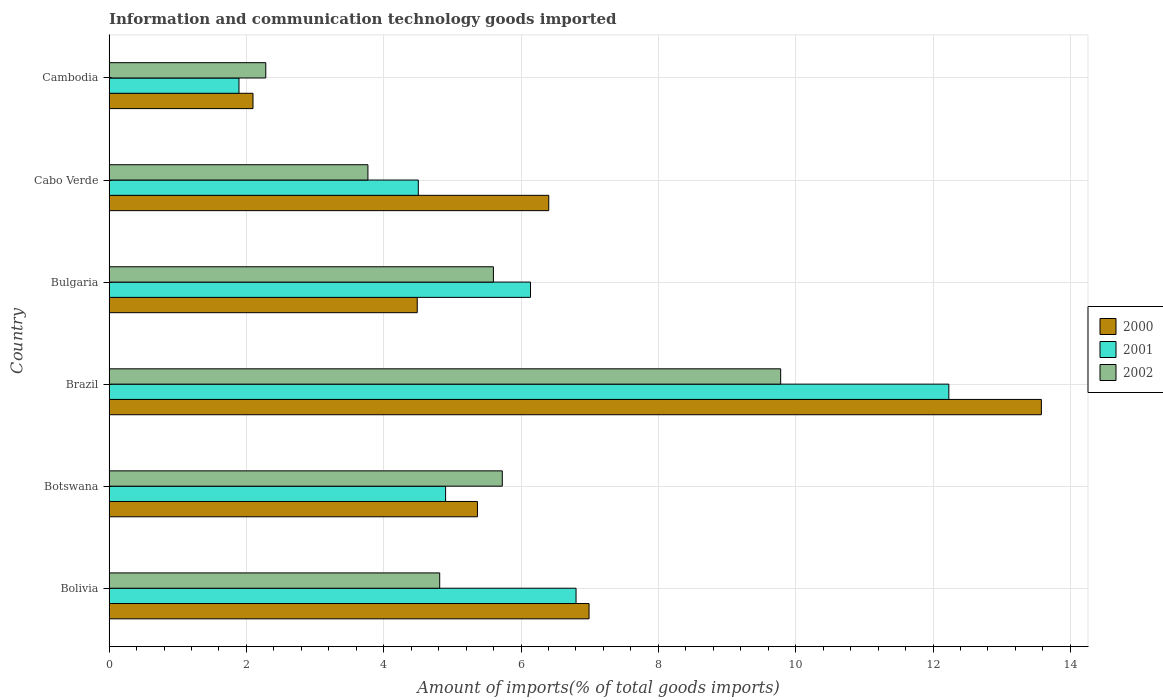Are the number of bars per tick equal to the number of legend labels?
Your response must be concise. Yes. How many bars are there on the 6th tick from the top?
Your answer should be very brief. 3. What is the amount of goods imported in 2002 in Botswana?
Give a very brief answer. 5.73. Across all countries, what is the maximum amount of goods imported in 2002?
Give a very brief answer. 9.78. Across all countries, what is the minimum amount of goods imported in 2000?
Keep it short and to the point. 2.1. In which country was the amount of goods imported in 2002 minimum?
Your answer should be very brief. Cambodia. What is the total amount of goods imported in 2002 in the graph?
Your response must be concise. 31.97. What is the difference between the amount of goods imported in 2002 in Botswana and that in Brazil?
Make the answer very short. -4.05. What is the difference between the amount of goods imported in 2002 in Brazil and the amount of goods imported in 2001 in Botswana?
Offer a terse response. 4.88. What is the average amount of goods imported in 2002 per country?
Give a very brief answer. 5.33. What is the difference between the amount of goods imported in 2001 and amount of goods imported in 2000 in Brazil?
Ensure brevity in your answer.  -1.35. In how many countries, is the amount of goods imported in 2000 greater than 9.2 %?
Offer a terse response. 1. What is the ratio of the amount of goods imported in 2001 in Bolivia to that in Bulgaria?
Keep it short and to the point. 1.11. Is the amount of goods imported in 2001 in Bolivia less than that in Brazil?
Ensure brevity in your answer.  Yes. Is the difference between the amount of goods imported in 2001 in Bolivia and Cambodia greater than the difference between the amount of goods imported in 2000 in Bolivia and Cambodia?
Offer a very short reply. Yes. What is the difference between the highest and the second highest amount of goods imported in 2001?
Ensure brevity in your answer.  5.43. What is the difference between the highest and the lowest amount of goods imported in 2002?
Make the answer very short. 7.5. In how many countries, is the amount of goods imported in 2002 greater than the average amount of goods imported in 2002 taken over all countries?
Offer a terse response. 3. Is the sum of the amount of goods imported in 2000 in Cabo Verde and Cambodia greater than the maximum amount of goods imported in 2001 across all countries?
Offer a very short reply. No. Is it the case that in every country, the sum of the amount of goods imported in 2001 and amount of goods imported in 2002 is greater than the amount of goods imported in 2000?
Your answer should be compact. Yes. How many bars are there?
Provide a short and direct response. 18. Are all the bars in the graph horizontal?
Ensure brevity in your answer.  Yes. How many countries are there in the graph?
Offer a very short reply. 6. What is the difference between two consecutive major ticks on the X-axis?
Give a very brief answer. 2. Are the values on the major ticks of X-axis written in scientific E-notation?
Give a very brief answer. No. How many legend labels are there?
Offer a very short reply. 3. How are the legend labels stacked?
Provide a succinct answer. Vertical. What is the title of the graph?
Make the answer very short. Information and communication technology goods imported. Does "1997" appear as one of the legend labels in the graph?
Offer a very short reply. No. What is the label or title of the X-axis?
Give a very brief answer. Amount of imports(% of total goods imports). What is the Amount of imports(% of total goods imports) of 2000 in Bolivia?
Your answer should be very brief. 6.99. What is the Amount of imports(% of total goods imports) in 2001 in Bolivia?
Offer a very short reply. 6.8. What is the Amount of imports(% of total goods imports) of 2002 in Bolivia?
Keep it short and to the point. 4.82. What is the Amount of imports(% of total goods imports) in 2000 in Botswana?
Your answer should be very brief. 5.37. What is the Amount of imports(% of total goods imports) in 2001 in Botswana?
Give a very brief answer. 4.9. What is the Amount of imports(% of total goods imports) in 2002 in Botswana?
Offer a very short reply. 5.73. What is the Amount of imports(% of total goods imports) in 2000 in Brazil?
Your answer should be compact. 13.58. What is the Amount of imports(% of total goods imports) of 2001 in Brazil?
Make the answer very short. 12.23. What is the Amount of imports(% of total goods imports) in 2002 in Brazil?
Make the answer very short. 9.78. What is the Amount of imports(% of total goods imports) of 2000 in Bulgaria?
Offer a terse response. 4.49. What is the Amount of imports(% of total goods imports) of 2001 in Bulgaria?
Ensure brevity in your answer.  6.14. What is the Amount of imports(% of total goods imports) in 2002 in Bulgaria?
Give a very brief answer. 5.6. What is the Amount of imports(% of total goods imports) of 2000 in Cabo Verde?
Your answer should be compact. 6.4. What is the Amount of imports(% of total goods imports) in 2001 in Cabo Verde?
Give a very brief answer. 4.5. What is the Amount of imports(% of total goods imports) of 2002 in Cabo Verde?
Your answer should be very brief. 3.77. What is the Amount of imports(% of total goods imports) of 2000 in Cambodia?
Give a very brief answer. 2.1. What is the Amount of imports(% of total goods imports) of 2001 in Cambodia?
Provide a short and direct response. 1.89. What is the Amount of imports(% of total goods imports) of 2002 in Cambodia?
Your response must be concise. 2.28. Across all countries, what is the maximum Amount of imports(% of total goods imports) of 2000?
Provide a short and direct response. 13.58. Across all countries, what is the maximum Amount of imports(% of total goods imports) in 2001?
Give a very brief answer. 12.23. Across all countries, what is the maximum Amount of imports(% of total goods imports) of 2002?
Your response must be concise. 9.78. Across all countries, what is the minimum Amount of imports(% of total goods imports) in 2000?
Your answer should be compact. 2.1. Across all countries, what is the minimum Amount of imports(% of total goods imports) in 2001?
Offer a very short reply. 1.89. Across all countries, what is the minimum Amount of imports(% of total goods imports) of 2002?
Make the answer very short. 2.28. What is the total Amount of imports(% of total goods imports) in 2000 in the graph?
Your answer should be very brief. 38.92. What is the total Amount of imports(% of total goods imports) of 2001 in the graph?
Provide a succinct answer. 36.47. What is the total Amount of imports(% of total goods imports) in 2002 in the graph?
Offer a terse response. 31.97. What is the difference between the Amount of imports(% of total goods imports) of 2000 in Bolivia and that in Botswana?
Keep it short and to the point. 1.63. What is the difference between the Amount of imports(% of total goods imports) of 2001 in Bolivia and that in Botswana?
Give a very brief answer. 1.9. What is the difference between the Amount of imports(% of total goods imports) in 2002 in Bolivia and that in Botswana?
Provide a succinct answer. -0.91. What is the difference between the Amount of imports(% of total goods imports) in 2000 in Bolivia and that in Brazil?
Ensure brevity in your answer.  -6.59. What is the difference between the Amount of imports(% of total goods imports) of 2001 in Bolivia and that in Brazil?
Provide a succinct answer. -5.43. What is the difference between the Amount of imports(% of total goods imports) of 2002 in Bolivia and that in Brazil?
Your answer should be compact. -4.97. What is the difference between the Amount of imports(% of total goods imports) of 2000 in Bolivia and that in Bulgaria?
Make the answer very short. 2.5. What is the difference between the Amount of imports(% of total goods imports) in 2001 in Bolivia and that in Bulgaria?
Offer a terse response. 0.66. What is the difference between the Amount of imports(% of total goods imports) of 2002 in Bolivia and that in Bulgaria?
Provide a succinct answer. -0.78. What is the difference between the Amount of imports(% of total goods imports) of 2000 in Bolivia and that in Cabo Verde?
Give a very brief answer. 0.59. What is the difference between the Amount of imports(% of total goods imports) in 2001 in Bolivia and that in Cabo Verde?
Keep it short and to the point. 2.3. What is the difference between the Amount of imports(% of total goods imports) in 2002 in Bolivia and that in Cabo Verde?
Provide a short and direct response. 1.05. What is the difference between the Amount of imports(% of total goods imports) of 2000 in Bolivia and that in Cambodia?
Offer a terse response. 4.89. What is the difference between the Amount of imports(% of total goods imports) in 2001 in Bolivia and that in Cambodia?
Keep it short and to the point. 4.91. What is the difference between the Amount of imports(% of total goods imports) in 2002 in Bolivia and that in Cambodia?
Offer a very short reply. 2.53. What is the difference between the Amount of imports(% of total goods imports) of 2000 in Botswana and that in Brazil?
Make the answer very short. -8.21. What is the difference between the Amount of imports(% of total goods imports) of 2001 in Botswana and that in Brazil?
Your answer should be very brief. -7.33. What is the difference between the Amount of imports(% of total goods imports) in 2002 in Botswana and that in Brazil?
Your response must be concise. -4.05. What is the difference between the Amount of imports(% of total goods imports) in 2000 in Botswana and that in Bulgaria?
Your response must be concise. 0.88. What is the difference between the Amount of imports(% of total goods imports) in 2001 in Botswana and that in Bulgaria?
Offer a very short reply. -1.24. What is the difference between the Amount of imports(% of total goods imports) of 2002 in Botswana and that in Bulgaria?
Give a very brief answer. 0.13. What is the difference between the Amount of imports(% of total goods imports) in 2000 in Botswana and that in Cabo Verde?
Give a very brief answer. -1.04. What is the difference between the Amount of imports(% of total goods imports) of 2001 in Botswana and that in Cabo Verde?
Offer a terse response. 0.4. What is the difference between the Amount of imports(% of total goods imports) of 2002 in Botswana and that in Cabo Verde?
Provide a succinct answer. 1.96. What is the difference between the Amount of imports(% of total goods imports) in 2000 in Botswana and that in Cambodia?
Offer a terse response. 3.27. What is the difference between the Amount of imports(% of total goods imports) of 2001 in Botswana and that in Cambodia?
Offer a terse response. 3.01. What is the difference between the Amount of imports(% of total goods imports) in 2002 in Botswana and that in Cambodia?
Your answer should be very brief. 3.44. What is the difference between the Amount of imports(% of total goods imports) in 2000 in Brazil and that in Bulgaria?
Offer a very short reply. 9.09. What is the difference between the Amount of imports(% of total goods imports) of 2001 in Brazil and that in Bulgaria?
Your response must be concise. 6.09. What is the difference between the Amount of imports(% of total goods imports) in 2002 in Brazil and that in Bulgaria?
Make the answer very short. 4.18. What is the difference between the Amount of imports(% of total goods imports) of 2000 in Brazil and that in Cabo Verde?
Provide a short and direct response. 7.17. What is the difference between the Amount of imports(% of total goods imports) in 2001 in Brazil and that in Cabo Verde?
Offer a very short reply. 7.73. What is the difference between the Amount of imports(% of total goods imports) of 2002 in Brazil and that in Cabo Verde?
Offer a terse response. 6.01. What is the difference between the Amount of imports(% of total goods imports) in 2000 in Brazil and that in Cambodia?
Your response must be concise. 11.48. What is the difference between the Amount of imports(% of total goods imports) of 2001 in Brazil and that in Cambodia?
Your response must be concise. 10.34. What is the difference between the Amount of imports(% of total goods imports) in 2002 in Brazil and that in Cambodia?
Offer a very short reply. 7.5. What is the difference between the Amount of imports(% of total goods imports) in 2000 in Bulgaria and that in Cabo Verde?
Provide a succinct answer. -1.92. What is the difference between the Amount of imports(% of total goods imports) of 2001 in Bulgaria and that in Cabo Verde?
Your answer should be compact. 1.63. What is the difference between the Amount of imports(% of total goods imports) of 2002 in Bulgaria and that in Cabo Verde?
Offer a terse response. 1.83. What is the difference between the Amount of imports(% of total goods imports) of 2000 in Bulgaria and that in Cambodia?
Ensure brevity in your answer.  2.39. What is the difference between the Amount of imports(% of total goods imports) in 2001 in Bulgaria and that in Cambodia?
Ensure brevity in your answer.  4.25. What is the difference between the Amount of imports(% of total goods imports) of 2002 in Bulgaria and that in Cambodia?
Give a very brief answer. 3.31. What is the difference between the Amount of imports(% of total goods imports) of 2000 in Cabo Verde and that in Cambodia?
Provide a short and direct response. 4.31. What is the difference between the Amount of imports(% of total goods imports) of 2001 in Cabo Verde and that in Cambodia?
Offer a terse response. 2.61. What is the difference between the Amount of imports(% of total goods imports) in 2002 in Cabo Verde and that in Cambodia?
Your response must be concise. 1.49. What is the difference between the Amount of imports(% of total goods imports) of 2000 in Bolivia and the Amount of imports(% of total goods imports) of 2001 in Botswana?
Provide a succinct answer. 2.09. What is the difference between the Amount of imports(% of total goods imports) of 2000 in Bolivia and the Amount of imports(% of total goods imports) of 2002 in Botswana?
Provide a succinct answer. 1.26. What is the difference between the Amount of imports(% of total goods imports) in 2001 in Bolivia and the Amount of imports(% of total goods imports) in 2002 in Botswana?
Your response must be concise. 1.07. What is the difference between the Amount of imports(% of total goods imports) in 2000 in Bolivia and the Amount of imports(% of total goods imports) in 2001 in Brazil?
Make the answer very short. -5.24. What is the difference between the Amount of imports(% of total goods imports) of 2000 in Bolivia and the Amount of imports(% of total goods imports) of 2002 in Brazil?
Offer a very short reply. -2.79. What is the difference between the Amount of imports(% of total goods imports) in 2001 in Bolivia and the Amount of imports(% of total goods imports) in 2002 in Brazil?
Your answer should be very brief. -2.98. What is the difference between the Amount of imports(% of total goods imports) of 2000 in Bolivia and the Amount of imports(% of total goods imports) of 2001 in Bulgaria?
Your answer should be very brief. 0.85. What is the difference between the Amount of imports(% of total goods imports) of 2000 in Bolivia and the Amount of imports(% of total goods imports) of 2002 in Bulgaria?
Offer a terse response. 1.39. What is the difference between the Amount of imports(% of total goods imports) in 2001 in Bolivia and the Amount of imports(% of total goods imports) in 2002 in Bulgaria?
Your answer should be very brief. 1.2. What is the difference between the Amount of imports(% of total goods imports) in 2000 in Bolivia and the Amount of imports(% of total goods imports) in 2001 in Cabo Verde?
Make the answer very short. 2.49. What is the difference between the Amount of imports(% of total goods imports) in 2000 in Bolivia and the Amount of imports(% of total goods imports) in 2002 in Cabo Verde?
Your answer should be very brief. 3.22. What is the difference between the Amount of imports(% of total goods imports) of 2001 in Bolivia and the Amount of imports(% of total goods imports) of 2002 in Cabo Verde?
Provide a short and direct response. 3.03. What is the difference between the Amount of imports(% of total goods imports) in 2000 in Bolivia and the Amount of imports(% of total goods imports) in 2001 in Cambodia?
Provide a succinct answer. 5.1. What is the difference between the Amount of imports(% of total goods imports) in 2000 in Bolivia and the Amount of imports(% of total goods imports) in 2002 in Cambodia?
Make the answer very short. 4.71. What is the difference between the Amount of imports(% of total goods imports) in 2001 in Bolivia and the Amount of imports(% of total goods imports) in 2002 in Cambodia?
Your answer should be compact. 4.52. What is the difference between the Amount of imports(% of total goods imports) in 2000 in Botswana and the Amount of imports(% of total goods imports) in 2001 in Brazil?
Offer a terse response. -6.87. What is the difference between the Amount of imports(% of total goods imports) of 2000 in Botswana and the Amount of imports(% of total goods imports) of 2002 in Brazil?
Your response must be concise. -4.42. What is the difference between the Amount of imports(% of total goods imports) of 2001 in Botswana and the Amount of imports(% of total goods imports) of 2002 in Brazil?
Make the answer very short. -4.88. What is the difference between the Amount of imports(% of total goods imports) of 2000 in Botswana and the Amount of imports(% of total goods imports) of 2001 in Bulgaria?
Your answer should be compact. -0.77. What is the difference between the Amount of imports(% of total goods imports) of 2000 in Botswana and the Amount of imports(% of total goods imports) of 2002 in Bulgaria?
Your answer should be compact. -0.23. What is the difference between the Amount of imports(% of total goods imports) in 2001 in Botswana and the Amount of imports(% of total goods imports) in 2002 in Bulgaria?
Ensure brevity in your answer.  -0.7. What is the difference between the Amount of imports(% of total goods imports) of 2000 in Botswana and the Amount of imports(% of total goods imports) of 2001 in Cabo Verde?
Your response must be concise. 0.86. What is the difference between the Amount of imports(% of total goods imports) in 2000 in Botswana and the Amount of imports(% of total goods imports) in 2002 in Cabo Verde?
Provide a short and direct response. 1.6. What is the difference between the Amount of imports(% of total goods imports) in 2001 in Botswana and the Amount of imports(% of total goods imports) in 2002 in Cabo Verde?
Your response must be concise. 1.13. What is the difference between the Amount of imports(% of total goods imports) of 2000 in Botswana and the Amount of imports(% of total goods imports) of 2001 in Cambodia?
Keep it short and to the point. 3.47. What is the difference between the Amount of imports(% of total goods imports) of 2000 in Botswana and the Amount of imports(% of total goods imports) of 2002 in Cambodia?
Your response must be concise. 3.08. What is the difference between the Amount of imports(% of total goods imports) in 2001 in Botswana and the Amount of imports(% of total goods imports) in 2002 in Cambodia?
Provide a succinct answer. 2.62. What is the difference between the Amount of imports(% of total goods imports) in 2000 in Brazil and the Amount of imports(% of total goods imports) in 2001 in Bulgaria?
Provide a short and direct response. 7.44. What is the difference between the Amount of imports(% of total goods imports) of 2000 in Brazil and the Amount of imports(% of total goods imports) of 2002 in Bulgaria?
Offer a very short reply. 7.98. What is the difference between the Amount of imports(% of total goods imports) of 2001 in Brazil and the Amount of imports(% of total goods imports) of 2002 in Bulgaria?
Offer a terse response. 6.63. What is the difference between the Amount of imports(% of total goods imports) of 2000 in Brazil and the Amount of imports(% of total goods imports) of 2001 in Cabo Verde?
Ensure brevity in your answer.  9.07. What is the difference between the Amount of imports(% of total goods imports) in 2000 in Brazil and the Amount of imports(% of total goods imports) in 2002 in Cabo Verde?
Give a very brief answer. 9.81. What is the difference between the Amount of imports(% of total goods imports) of 2001 in Brazil and the Amount of imports(% of total goods imports) of 2002 in Cabo Verde?
Provide a short and direct response. 8.46. What is the difference between the Amount of imports(% of total goods imports) in 2000 in Brazil and the Amount of imports(% of total goods imports) in 2001 in Cambodia?
Your answer should be compact. 11.69. What is the difference between the Amount of imports(% of total goods imports) in 2000 in Brazil and the Amount of imports(% of total goods imports) in 2002 in Cambodia?
Your answer should be compact. 11.3. What is the difference between the Amount of imports(% of total goods imports) in 2001 in Brazil and the Amount of imports(% of total goods imports) in 2002 in Cambodia?
Your answer should be compact. 9.95. What is the difference between the Amount of imports(% of total goods imports) in 2000 in Bulgaria and the Amount of imports(% of total goods imports) in 2001 in Cabo Verde?
Make the answer very short. -0.02. What is the difference between the Amount of imports(% of total goods imports) in 2000 in Bulgaria and the Amount of imports(% of total goods imports) in 2002 in Cabo Verde?
Your answer should be very brief. 0.72. What is the difference between the Amount of imports(% of total goods imports) in 2001 in Bulgaria and the Amount of imports(% of total goods imports) in 2002 in Cabo Verde?
Ensure brevity in your answer.  2.37. What is the difference between the Amount of imports(% of total goods imports) of 2000 in Bulgaria and the Amount of imports(% of total goods imports) of 2001 in Cambodia?
Your answer should be compact. 2.6. What is the difference between the Amount of imports(% of total goods imports) of 2000 in Bulgaria and the Amount of imports(% of total goods imports) of 2002 in Cambodia?
Provide a short and direct response. 2.21. What is the difference between the Amount of imports(% of total goods imports) of 2001 in Bulgaria and the Amount of imports(% of total goods imports) of 2002 in Cambodia?
Provide a succinct answer. 3.86. What is the difference between the Amount of imports(% of total goods imports) of 2000 in Cabo Verde and the Amount of imports(% of total goods imports) of 2001 in Cambodia?
Provide a succinct answer. 4.51. What is the difference between the Amount of imports(% of total goods imports) in 2000 in Cabo Verde and the Amount of imports(% of total goods imports) in 2002 in Cambodia?
Offer a very short reply. 4.12. What is the difference between the Amount of imports(% of total goods imports) in 2001 in Cabo Verde and the Amount of imports(% of total goods imports) in 2002 in Cambodia?
Keep it short and to the point. 2.22. What is the average Amount of imports(% of total goods imports) in 2000 per country?
Keep it short and to the point. 6.49. What is the average Amount of imports(% of total goods imports) of 2001 per country?
Your answer should be compact. 6.08. What is the average Amount of imports(% of total goods imports) in 2002 per country?
Offer a terse response. 5.33. What is the difference between the Amount of imports(% of total goods imports) in 2000 and Amount of imports(% of total goods imports) in 2001 in Bolivia?
Provide a succinct answer. 0.19. What is the difference between the Amount of imports(% of total goods imports) of 2000 and Amount of imports(% of total goods imports) of 2002 in Bolivia?
Give a very brief answer. 2.17. What is the difference between the Amount of imports(% of total goods imports) of 2001 and Amount of imports(% of total goods imports) of 2002 in Bolivia?
Your response must be concise. 1.99. What is the difference between the Amount of imports(% of total goods imports) in 2000 and Amount of imports(% of total goods imports) in 2001 in Botswana?
Your response must be concise. 0.46. What is the difference between the Amount of imports(% of total goods imports) of 2000 and Amount of imports(% of total goods imports) of 2002 in Botswana?
Provide a succinct answer. -0.36. What is the difference between the Amount of imports(% of total goods imports) in 2001 and Amount of imports(% of total goods imports) in 2002 in Botswana?
Keep it short and to the point. -0.83. What is the difference between the Amount of imports(% of total goods imports) in 2000 and Amount of imports(% of total goods imports) in 2001 in Brazil?
Provide a succinct answer. 1.35. What is the difference between the Amount of imports(% of total goods imports) in 2000 and Amount of imports(% of total goods imports) in 2002 in Brazil?
Your answer should be compact. 3.8. What is the difference between the Amount of imports(% of total goods imports) of 2001 and Amount of imports(% of total goods imports) of 2002 in Brazil?
Your answer should be very brief. 2.45. What is the difference between the Amount of imports(% of total goods imports) of 2000 and Amount of imports(% of total goods imports) of 2001 in Bulgaria?
Your response must be concise. -1.65. What is the difference between the Amount of imports(% of total goods imports) in 2000 and Amount of imports(% of total goods imports) in 2002 in Bulgaria?
Your response must be concise. -1.11. What is the difference between the Amount of imports(% of total goods imports) of 2001 and Amount of imports(% of total goods imports) of 2002 in Bulgaria?
Your answer should be very brief. 0.54. What is the difference between the Amount of imports(% of total goods imports) of 2000 and Amount of imports(% of total goods imports) of 2001 in Cabo Verde?
Offer a terse response. 1.9. What is the difference between the Amount of imports(% of total goods imports) of 2000 and Amount of imports(% of total goods imports) of 2002 in Cabo Verde?
Provide a succinct answer. 2.63. What is the difference between the Amount of imports(% of total goods imports) of 2001 and Amount of imports(% of total goods imports) of 2002 in Cabo Verde?
Provide a succinct answer. 0.73. What is the difference between the Amount of imports(% of total goods imports) of 2000 and Amount of imports(% of total goods imports) of 2001 in Cambodia?
Give a very brief answer. 0.2. What is the difference between the Amount of imports(% of total goods imports) of 2000 and Amount of imports(% of total goods imports) of 2002 in Cambodia?
Keep it short and to the point. -0.19. What is the difference between the Amount of imports(% of total goods imports) in 2001 and Amount of imports(% of total goods imports) in 2002 in Cambodia?
Make the answer very short. -0.39. What is the ratio of the Amount of imports(% of total goods imports) in 2000 in Bolivia to that in Botswana?
Offer a terse response. 1.3. What is the ratio of the Amount of imports(% of total goods imports) of 2001 in Bolivia to that in Botswana?
Keep it short and to the point. 1.39. What is the ratio of the Amount of imports(% of total goods imports) in 2002 in Bolivia to that in Botswana?
Offer a very short reply. 0.84. What is the ratio of the Amount of imports(% of total goods imports) of 2000 in Bolivia to that in Brazil?
Offer a terse response. 0.51. What is the ratio of the Amount of imports(% of total goods imports) in 2001 in Bolivia to that in Brazil?
Give a very brief answer. 0.56. What is the ratio of the Amount of imports(% of total goods imports) in 2002 in Bolivia to that in Brazil?
Make the answer very short. 0.49. What is the ratio of the Amount of imports(% of total goods imports) of 2000 in Bolivia to that in Bulgaria?
Offer a very short reply. 1.56. What is the ratio of the Amount of imports(% of total goods imports) of 2001 in Bolivia to that in Bulgaria?
Your answer should be very brief. 1.11. What is the ratio of the Amount of imports(% of total goods imports) in 2002 in Bolivia to that in Bulgaria?
Your answer should be compact. 0.86. What is the ratio of the Amount of imports(% of total goods imports) in 2000 in Bolivia to that in Cabo Verde?
Keep it short and to the point. 1.09. What is the ratio of the Amount of imports(% of total goods imports) of 2001 in Bolivia to that in Cabo Verde?
Your response must be concise. 1.51. What is the ratio of the Amount of imports(% of total goods imports) of 2002 in Bolivia to that in Cabo Verde?
Make the answer very short. 1.28. What is the ratio of the Amount of imports(% of total goods imports) of 2000 in Bolivia to that in Cambodia?
Your answer should be compact. 3.33. What is the ratio of the Amount of imports(% of total goods imports) in 2001 in Bolivia to that in Cambodia?
Provide a short and direct response. 3.59. What is the ratio of the Amount of imports(% of total goods imports) of 2002 in Bolivia to that in Cambodia?
Provide a succinct answer. 2.11. What is the ratio of the Amount of imports(% of total goods imports) of 2000 in Botswana to that in Brazil?
Make the answer very short. 0.4. What is the ratio of the Amount of imports(% of total goods imports) of 2001 in Botswana to that in Brazil?
Your answer should be compact. 0.4. What is the ratio of the Amount of imports(% of total goods imports) in 2002 in Botswana to that in Brazil?
Keep it short and to the point. 0.59. What is the ratio of the Amount of imports(% of total goods imports) in 2000 in Botswana to that in Bulgaria?
Your answer should be very brief. 1.2. What is the ratio of the Amount of imports(% of total goods imports) in 2001 in Botswana to that in Bulgaria?
Provide a short and direct response. 0.8. What is the ratio of the Amount of imports(% of total goods imports) in 2002 in Botswana to that in Bulgaria?
Offer a terse response. 1.02. What is the ratio of the Amount of imports(% of total goods imports) of 2000 in Botswana to that in Cabo Verde?
Offer a very short reply. 0.84. What is the ratio of the Amount of imports(% of total goods imports) of 2001 in Botswana to that in Cabo Verde?
Keep it short and to the point. 1.09. What is the ratio of the Amount of imports(% of total goods imports) in 2002 in Botswana to that in Cabo Verde?
Make the answer very short. 1.52. What is the ratio of the Amount of imports(% of total goods imports) of 2000 in Botswana to that in Cambodia?
Offer a very short reply. 2.56. What is the ratio of the Amount of imports(% of total goods imports) in 2001 in Botswana to that in Cambodia?
Ensure brevity in your answer.  2.59. What is the ratio of the Amount of imports(% of total goods imports) of 2002 in Botswana to that in Cambodia?
Give a very brief answer. 2.51. What is the ratio of the Amount of imports(% of total goods imports) in 2000 in Brazil to that in Bulgaria?
Give a very brief answer. 3.03. What is the ratio of the Amount of imports(% of total goods imports) in 2001 in Brazil to that in Bulgaria?
Make the answer very short. 1.99. What is the ratio of the Amount of imports(% of total goods imports) of 2002 in Brazil to that in Bulgaria?
Offer a very short reply. 1.75. What is the ratio of the Amount of imports(% of total goods imports) of 2000 in Brazil to that in Cabo Verde?
Keep it short and to the point. 2.12. What is the ratio of the Amount of imports(% of total goods imports) in 2001 in Brazil to that in Cabo Verde?
Your response must be concise. 2.72. What is the ratio of the Amount of imports(% of total goods imports) in 2002 in Brazil to that in Cabo Verde?
Offer a terse response. 2.59. What is the ratio of the Amount of imports(% of total goods imports) in 2000 in Brazil to that in Cambodia?
Offer a terse response. 6.48. What is the ratio of the Amount of imports(% of total goods imports) in 2001 in Brazil to that in Cambodia?
Make the answer very short. 6.46. What is the ratio of the Amount of imports(% of total goods imports) in 2002 in Brazil to that in Cambodia?
Provide a short and direct response. 4.29. What is the ratio of the Amount of imports(% of total goods imports) in 2000 in Bulgaria to that in Cabo Verde?
Ensure brevity in your answer.  0.7. What is the ratio of the Amount of imports(% of total goods imports) in 2001 in Bulgaria to that in Cabo Verde?
Offer a very short reply. 1.36. What is the ratio of the Amount of imports(% of total goods imports) in 2002 in Bulgaria to that in Cabo Verde?
Ensure brevity in your answer.  1.48. What is the ratio of the Amount of imports(% of total goods imports) of 2000 in Bulgaria to that in Cambodia?
Make the answer very short. 2.14. What is the ratio of the Amount of imports(% of total goods imports) in 2001 in Bulgaria to that in Cambodia?
Your answer should be compact. 3.24. What is the ratio of the Amount of imports(% of total goods imports) of 2002 in Bulgaria to that in Cambodia?
Make the answer very short. 2.45. What is the ratio of the Amount of imports(% of total goods imports) in 2000 in Cabo Verde to that in Cambodia?
Offer a terse response. 3.05. What is the ratio of the Amount of imports(% of total goods imports) in 2001 in Cabo Verde to that in Cambodia?
Offer a terse response. 2.38. What is the ratio of the Amount of imports(% of total goods imports) in 2002 in Cabo Verde to that in Cambodia?
Provide a short and direct response. 1.65. What is the difference between the highest and the second highest Amount of imports(% of total goods imports) in 2000?
Ensure brevity in your answer.  6.59. What is the difference between the highest and the second highest Amount of imports(% of total goods imports) of 2001?
Provide a succinct answer. 5.43. What is the difference between the highest and the second highest Amount of imports(% of total goods imports) of 2002?
Keep it short and to the point. 4.05. What is the difference between the highest and the lowest Amount of imports(% of total goods imports) in 2000?
Keep it short and to the point. 11.48. What is the difference between the highest and the lowest Amount of imports(% of total goods imports) of 2001?
Offer a terse response. 10.34. What is the difference between the highest and the lowest Amount of imports(% of total goods imports) in 2002?
Make the answer very short. 7.5. 